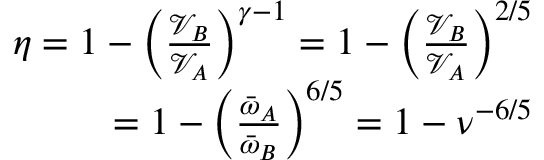Convert formula to latex. <formula><loc_0><loc_0><loc_500><loc_500>\begin{array} { r } { \eta = 1 - \left ( \frac { \mathcal { V } _ { B } } { \mathcal { V } _ { A } } \right ) ^ { \gamma - 1 } = 1 - \left ( \frac { \mathcal { V } _ { B } } { \mathcal { V } _ { A } } \right ) ^ { 2 / 5 } } \\ { = 1 - \left ( \frac { \bar { \omega } _ { A } } { \bar { \omega } _ { B } } \right ) ^ { 6 / 5 } = 1 - \nu ^ { - 6 / 5 } } \end{array}</formula> 